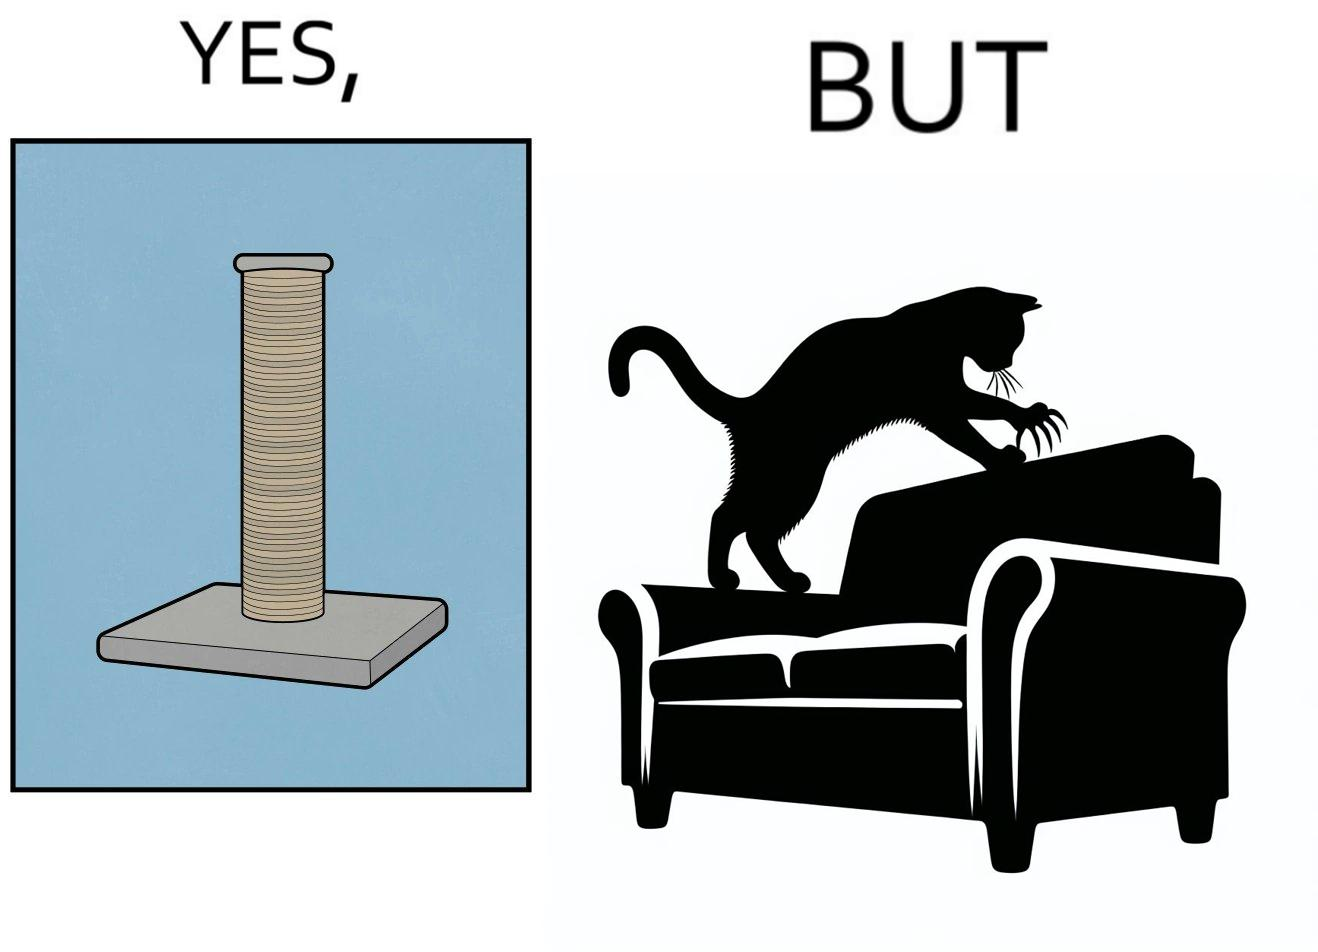What makes this image funny or satirical? The image is ironic, because in the first image a toy, purposed for the cat to play with is shown but in the second image the cat is comfortably enjoying  to play on the sides of sofa 